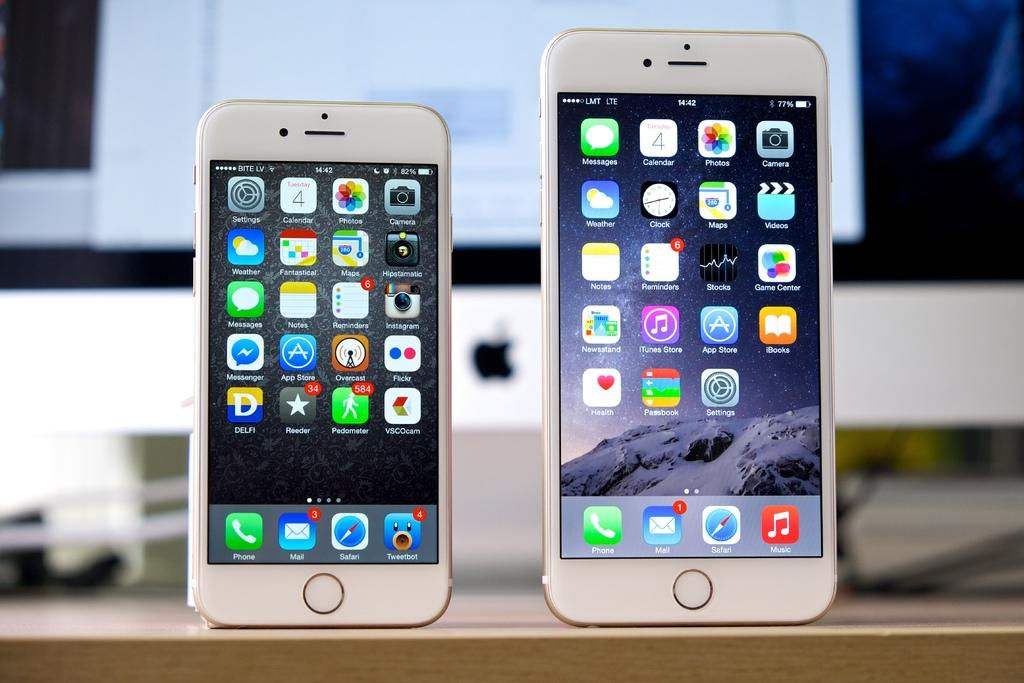<image>
Offer a succinct explanation of the picture presented. A smaller iphone is sitting on a wooden surface, next to a larger iphone with the apps showing on the screen. 